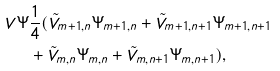<formula> <loc_0><loc_0><loc_500><loc_500>V \Psi & \frac { 1 } { 4 } ( \tilde { V } _ { m + 1 , n } \Psi _ { m + 1 , n } + \tilde { V } _ { m + 1 , n + 1 } \Psi _ { m + 1 , n + 1 } \\ & + \tilde { V } _ { m , n } \Psi _ { m , n } + \tilde { V } _ { m , n + 1 } \Psi _ { m , n + 1 } ) ,</formula> 